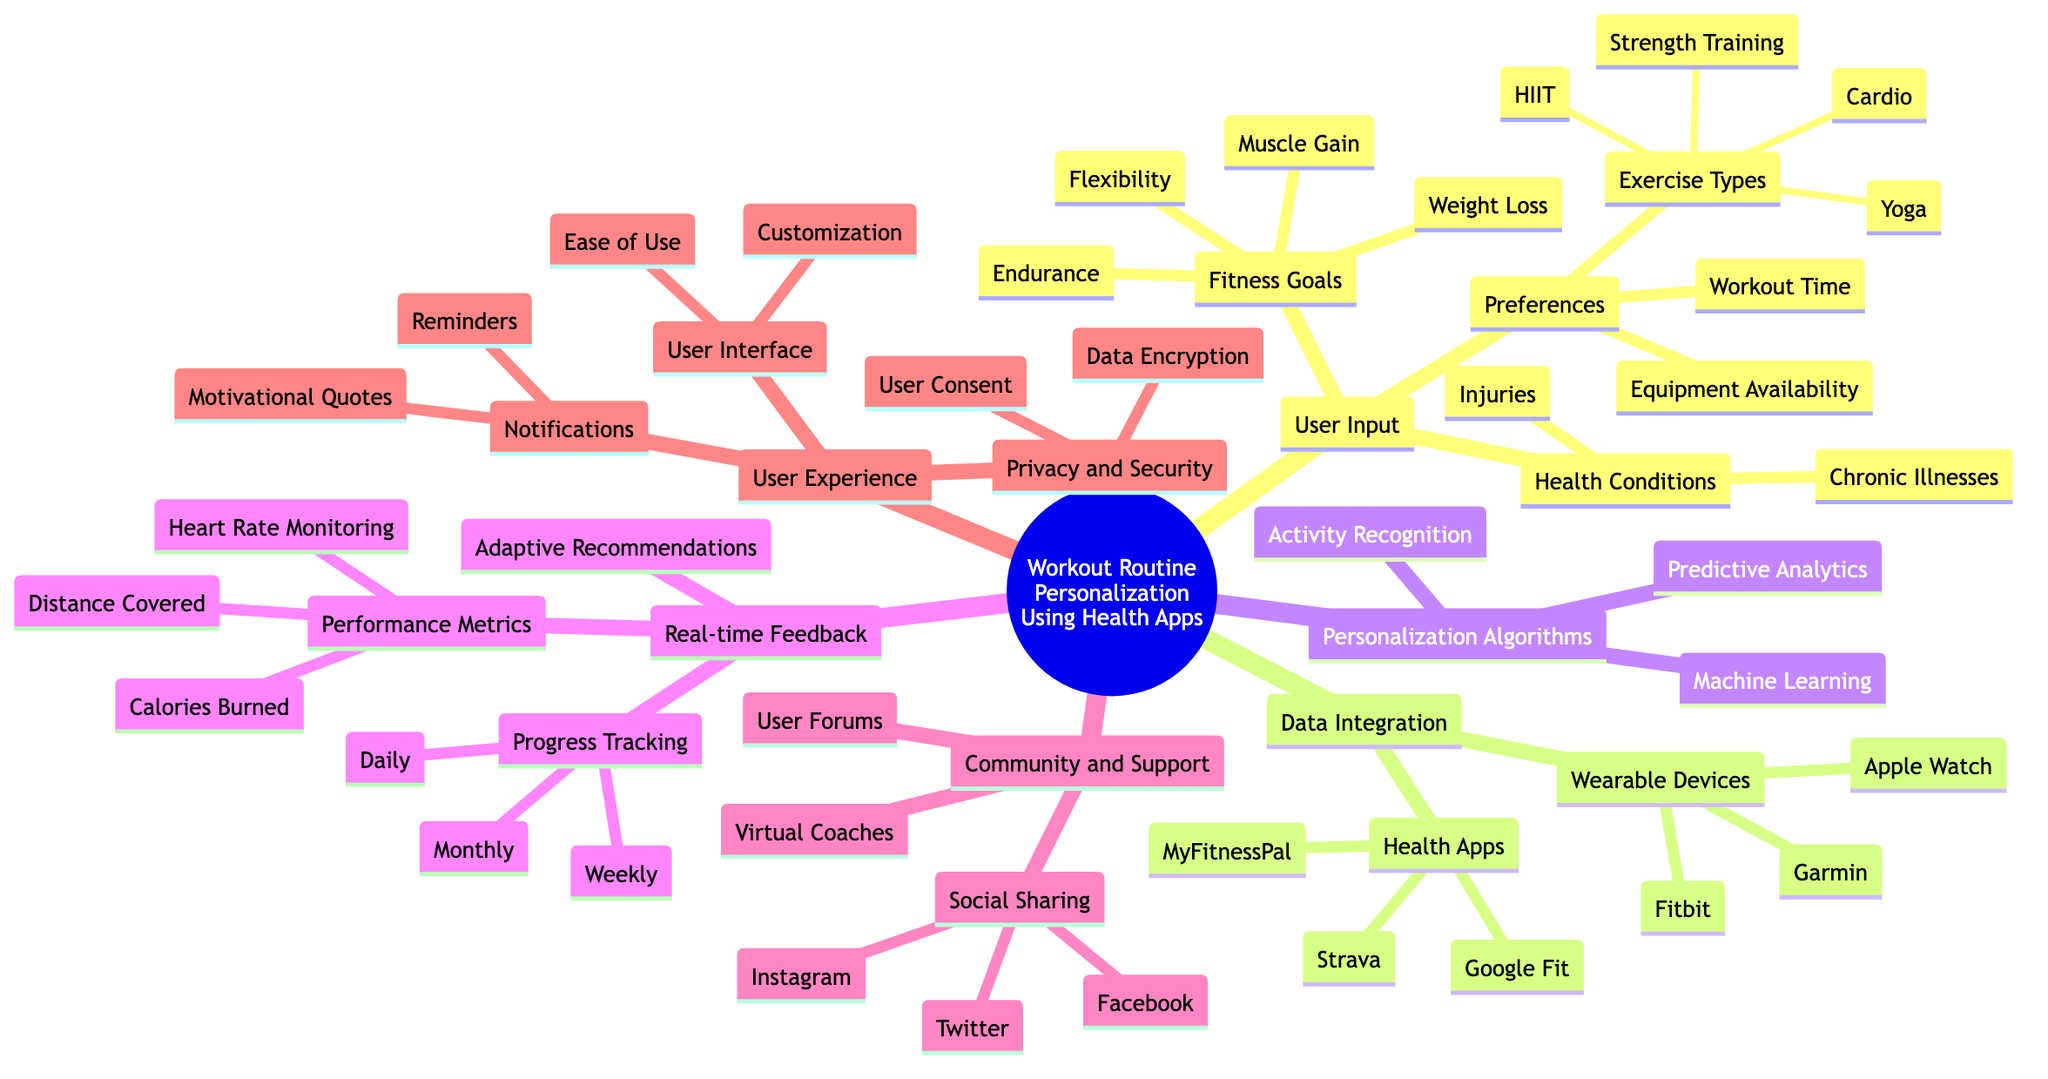What are the three main categories under User Input? The main categories under User Input listed in the diagram are Fitness Goals, Health Conditions, and Preferences.
Answer: Fitness Goals, Health Conditions, Preferences How many exercise types are listed under Preferences? Within Preferences, there are four exercise types mentioned: Cardio, Strength Training, Yoga, and HIIT.
Answer: Four What are the three wearable devices mentioned in the Data Integration section? The three wearable devices listed in the Data Integration section are Fitbit, Apple Watch, and Garmin.
Answer: Fitbit, Apple Watch, Garmin Which section provides real-time performance metrics? The section that addresses real-time performance metrics is Real-time Feedback, where specific metrics like Heart Rate Monitoring, Calories Burned, and Distance Covered are discussed.
Answer: Real-time Feedback What type of algorithms are used for personalization? The Personalization Algorithms in the diagram include Machine Learning, Activity Recognition, and Predictive Analytics, which are all techniques for creating personalized workout routines.
Answer: Machine Learning, Activity Recognition, Predictive Analytics What is one feature of the User Experience related to Notifications? Under User Experience, the Notifications category includes Reminders, which serves to help users stay on track with their workout goals.
Answer: Reminders What is the focus of the Community and Support section? The Community and Support section focuses on providing resources like Virtual Coaches, User Forums, and Social Sharing options to enhance user engagement and support.
Answer: Virtual Coaches, User Forums, Social Sharing How often can progress tracking be reviewed according to the diagram? Progress Tracking can be reviewed Daily, Weekly, and Monthly according to the diagram, allowing users to evaluate their progress over different time frames.
Answer: Daily, Weekly, Monthly What does the Privacy and Security section ensure? The Privacy and Security section ensures Data Encryption and User Consent, which are vital for safeguarding user information within health apps.
Answer: Data Encryption, User Consent 